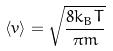<formula> <loc_0><loc_0><loc_500><loc_500>\langle v \rangle = \sqrt { \frac { 8 k _ { B } T } { \pi m } }</formula> 